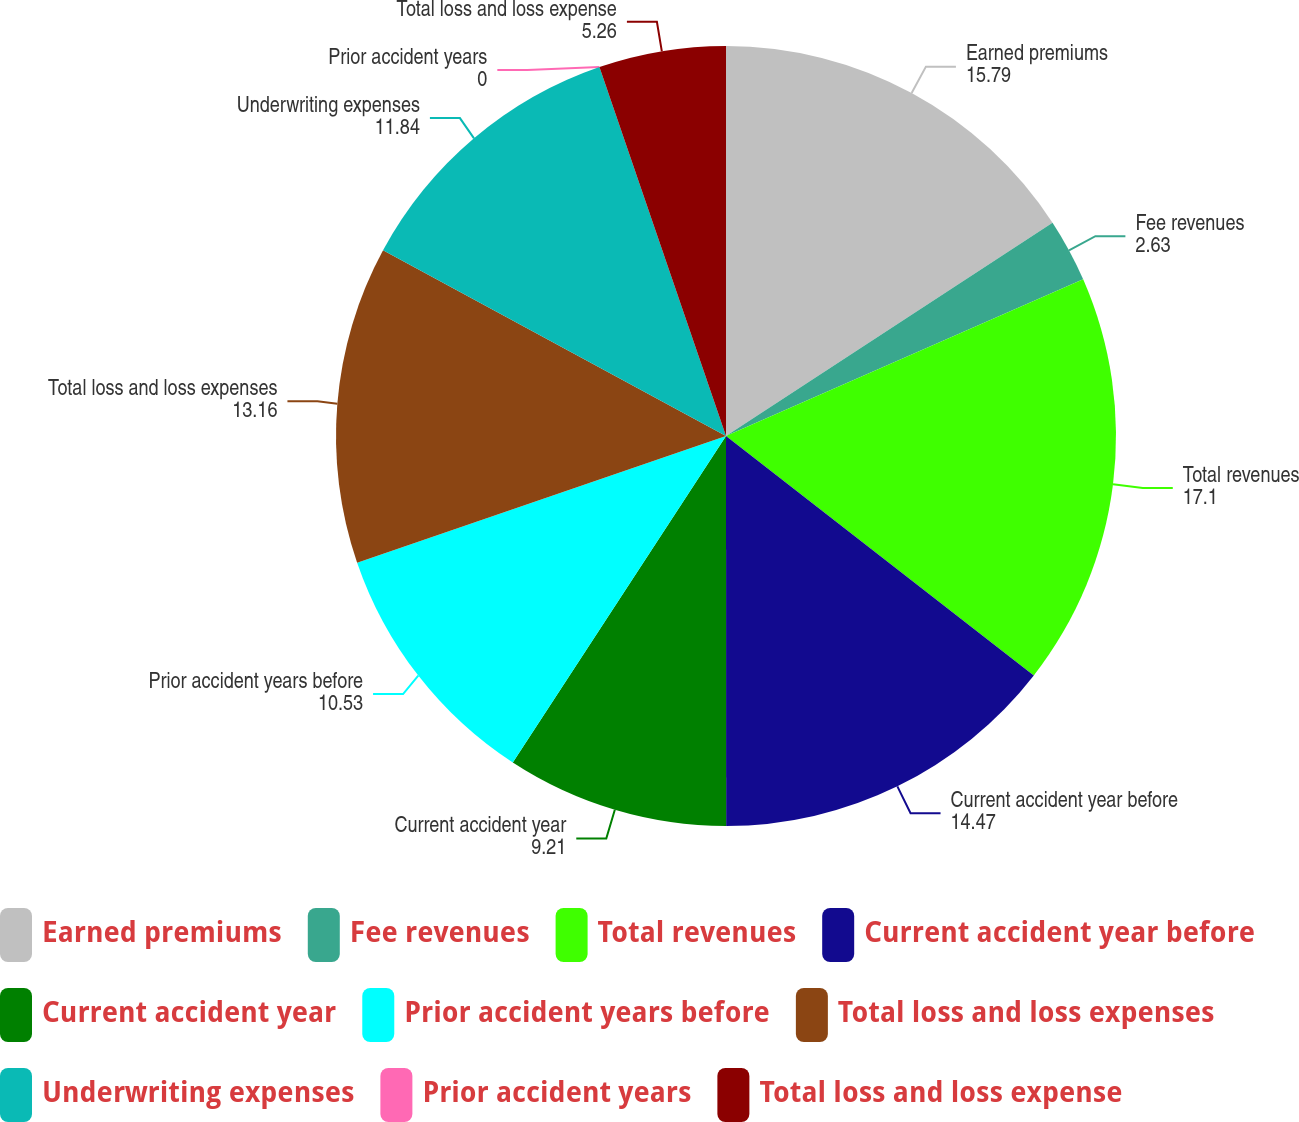Convert chart. <chart><loc_0><loc_0><loc_500><loc_500><pie_chart><fcel>Earned premiums<fcel>Fee revenues<fcel>Total revenues<fcel>Current accident year before<fcel>Current accident year<fcel>Prior accident years before<fcel>Total loss and loss expenses<fcel>Underwriting expenses<fcel>Prior accident years<fcel>Total loss and loss expense<nl><fcel>15.79%<fcel>2.63%<fcel>17.1%<fcel>14.47%<fcel>9.21%<fcel>10.53%<fcel>13.16%<fcel>11.84%<fcel>0.0%<fcel>5.26%<nl></chart> 